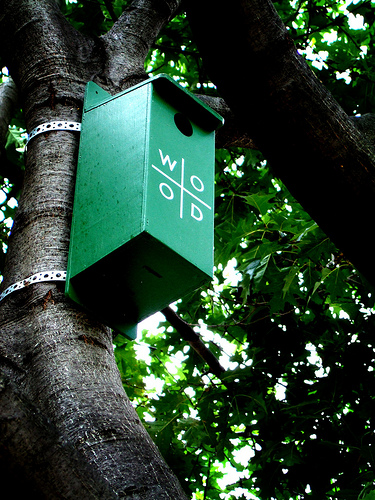<image>
Is the tree behind the box? Yes. From this viewpoint, the tree is positioned behind the box, with the box partially or fully occluding the tree. Is the letter on the birdhouse? Yes. Looking at the image, I can see the letter is positioned on top of the birdhouse, with the birdhouse providing support. 